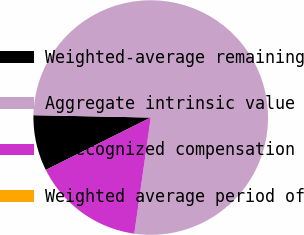Convert chart. <chart><loc_0><loc_0><loc_500><loc_500><pie_chart><fcel>Weighted-average remaining<fcel>Aggregate intrinsic value<fcel>Unrecognized compensation<fcel>Weighted average period of<nl><fcel>7.69%<fcel>76.92%<fcel>15.39%<fcel>0.0%<nl></chart> 